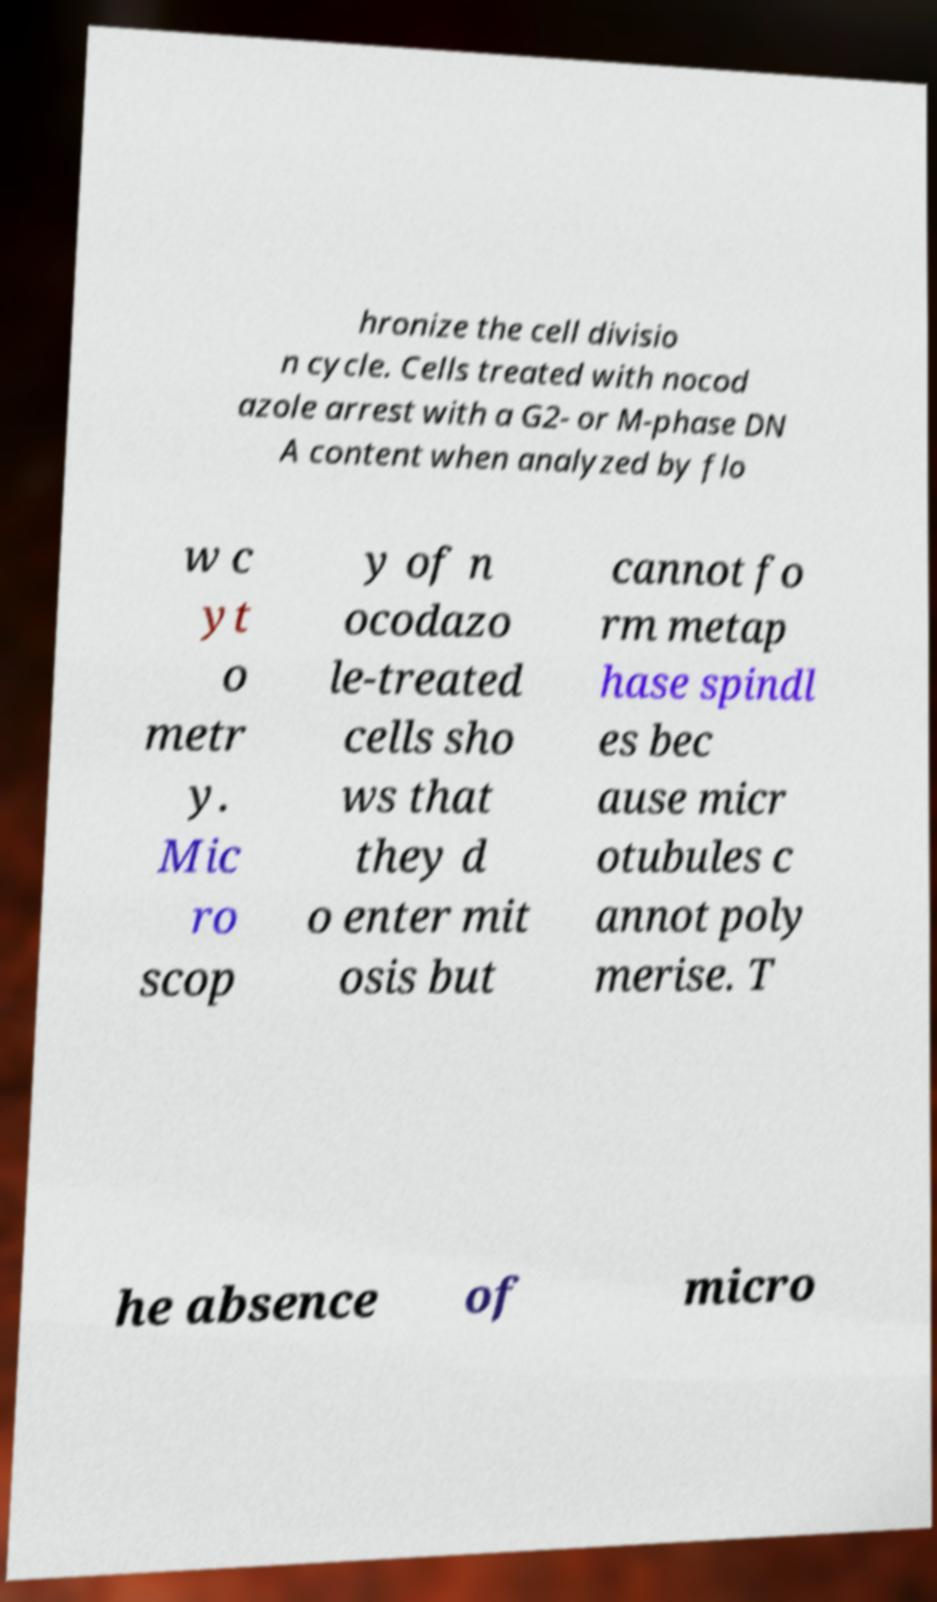For documentation purposes, I need the text within this image transcribed. Could you provide that? hronize the cell divisio n cycle. Cells treated with nocod azole arrest with a G2- or M-phase DN A content when analyzed by flo w c yt o metr y. Mic ro scop y of n ocodazo le-treated cells sho ws that they d o enter mit osis but cannot fo rm metap hase spindl es bec ause micr otubules c annot poly merise. T he absence of micro 